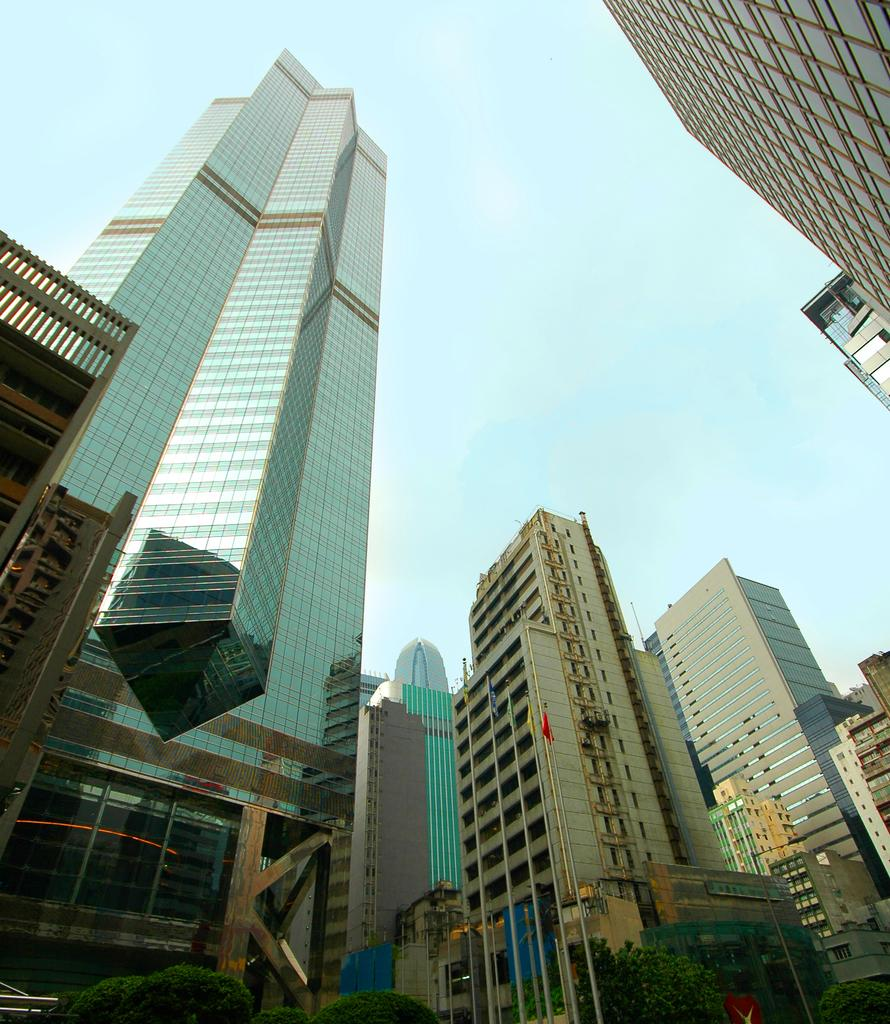What type of structure is present in the image? There is a building in the image. What can be seen attached to the building? There are flags and poles in the image. What type of vegetation is visible in the image? There are trees in the image. What is visible in the background of the image? The sky is visible in the background of the image. What type of clouds can be seen in the image? There are no clouds visible in the image; only the sky is visible in the background. 